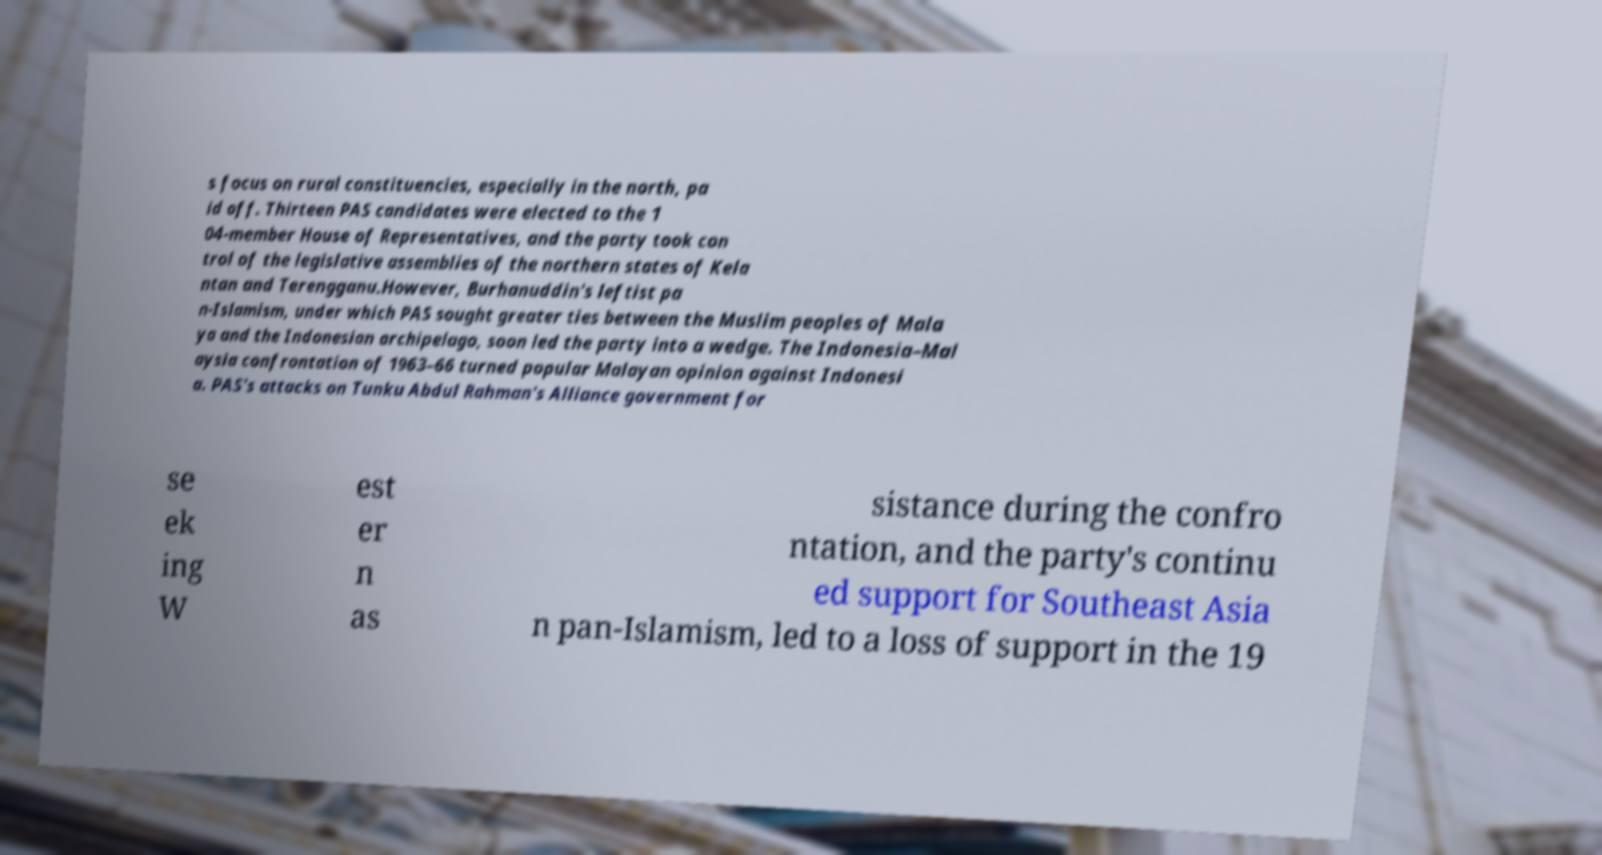There's text embedded in this image that I need extracted. Can you transcribe it verbatim? s focus on rural constituencies, especially in the north, pa id off. Thirteen PAS candidates were elected to the 1 04-member House of Representatives, and the party took con trol of the legislative assemblies of the northern states of Kela ntan and Terengganu.However, Burhanuddin's leftist pa n-Islamism, under which PAS sought greater ties between the Muslim peoples of Mala ya and the Indonesian archipelago, soon led the party into a wedge. The Indonesia–Mal aysia confrontation of 1963–66 turned popular Malayan opinion against Indonesi a. PAS's attacks on Tunku Abdul Rahman's Alliance government for se ek ing W est er n as sistance during the confro ntation, and the party's continu ed support for Southeast Asia n pan-Islamism, led to a loss of support in the 19 